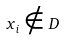<formula> <loc_0><loc_0><loc_500><loc_500>x _ { i } \notin D</formula> 